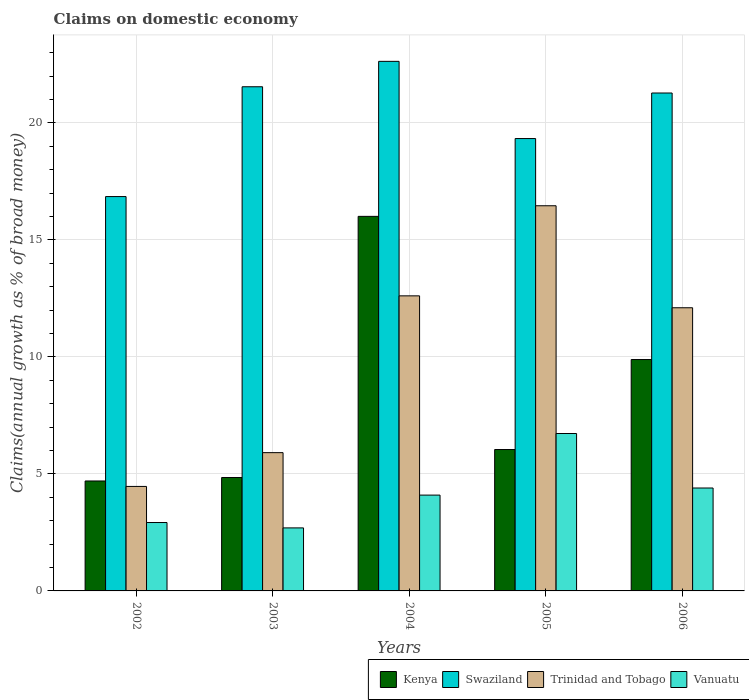How many different coloured bars are there?
Your response must be concise. 4. How many groups of bars are there?
Give a very brief answer. 5. Are the number of bars per tick equal to the number of legend labels?
Offer a terse response. Yes. How many bars are there on the 4th tick from the right?
Provide a short and direct response. 4. In how many cases, is the number of bars for a given year not equal to the number of legend labels?
Provide a succinct answer. 0. What is the percentage of broad money claimed on domestic economy in Kenya in 2004?
Your answer should be very brief. 16. Across all years, what is the maximum percentage of broad money claimed on domestic economy in Kenya?
Ensure brevity in your answer.  16. Across all years, what is the minimum percentage of broad money claimed on domestic economy in Swaziland?
Offer a terse response. 16.85. What is the total percentage of broad money claimed on domestic economy in Kenya in the graph?
Provide a succinct answer. 41.47. What is the difference between the percentage of broad money claimed on domestic economy in Vanuatu in 2004 and that in 2005?
Make the answer very short. -2.63. What is the difference between the percentage of broad money claimed on domestic economy in Swaziland in 2005 and the percentage of broad money claimed on domestic economy in Trinidad and Tobago in 2006?
Provide a short and direct response. 7.23. What is the average percentage of broad money claimed on domestic economy in Swaziland per year?
Your response must be concise. 20.32. In the year 2006, what is the difference between the percentage of broad money claimed on domestic economy in Swaziland and percentage of broad money claimed on domestic economy in Trinidad and Tobago?
Your response must be concise. 9.18. In how many years, is the percentage of broad money claimed on domestic economy in Trinidad and Tobago greater than 1 %?
Your response must be concise. 5. What is the ratio of the percentage of broad money claimed on domestic economy in Vanuatu in 2002 to that in 2004?
Provide a succinct answer. 0.71. What is the difference between the highest and the second highest percentage of broad money claimed on domestic economy in Kenya?
Keep it short and to the point. 6.12. What is the difference between the highest and the lowest percentage of broad money claimed on domestic economy in Kenya?
Your answer should be very brief. 11.31. In how many years, is the percentage of broad money claimed on domestic economy in Trinidad and Tobago greater than the average percentage of broad money claimed on domestic economy in Trinidad and Tobago taken over all years?
Provide a short and direct response. 3. Is the sum of the percentage of broad money claimed on domestic economy in Swaziland in 2003 and 2006 greater than the maximum percentage of broad money claimed on domestic economy in Vanuatu across all years?
Keep it short and to the point. Yes. What does the 4th bar from the left in 2006 represents?
Provide a short and direct response. Vanuatu. What does the 1st bar from the right in 2005 represents?
Make the answer very short. Vanuatu. How many bars are there?
Offer a very short reply. 20. Are all the bars in the graph horizontal?
Your response must be concise. No. How many years are there in the graph?
Your answer should be very brief. 5. Does the graph contain any zero values?
Provide a short and direct response. No. Does the graph contain grids?
Offer a very short reply. Yes. Where does the legend appear in the graph?
Your answer should be compact. Bottom right. How are the legend labels stacked?
Your response must be concise. Horizontal. What is the title of the graph?
Offer a terse response. Claims on domestic economy. What is the label or title of the Y-axis?
Your answer should be very brief. Claims(annual growth as % of broad money). What is the Claims(annual growth as % of broad money) of Kenya in 2002?
Offer a terse response. 4.7. What is the Claims(annual growth as % of broad money) of Swaziland in 2002?
Offer a very short reply. 16.85. What is the Claims(annual growth as % of broad money) in Trinidad and Tobago in 2002?
Offer a very short reply. 4.46. What is the Claims(annual growth as % of broad money) in Vanuatu in 2002?
Make the answer very short. 2.92. What is the Claims(annual growth as % of broad money) of Kenya in 2003?
Ensure brevity in your answer.  4.84. What is the Claims(annual growth as % of broad money) of Swaziland in 2003?
Your response must be concise. 21.54. What is the Claims(annual growth as % of broad money) of Trinidad and Tobago in 2003?
Provide a succinct answer. 5.91. What is the Claims(annual growth as % of broad money) in Vanuatu in 2003?
Keep it short and to the point. 2.69. What is the Claims(annual growth as % of broad money) in Kenya in 2004?
Provide a short and direct response. 16. What is the Claims(annual growth as % of broad money) of Swaziland in 2004?
Your answer should be very brief. 22.63. What is the Claims(annual growth as % of broad money) of Trinidad and Tobago in 2004?
Give a very brief answer. 12.61. What is the Claims(annual growth as % of broad money) of Vanuatu in 2004?
Offer a terse response. 4.09. What is the Claims(annual growth as % of broad money) in Kenya in 2005?
Offer a very short reply. 6.04. What is the Claims(annual growth as % of broad money) of Swaziland in 2005?
Your answer should be very brief. 19.33. What is the Claims(annual growth as % of broad money) in Trinidad and Tobago in 2005?
Provide a succinct answer. 16.46. What is the Claims(annual growth as % of broad money) in Vanuatu in 2005?
Your answer should be very brief. 6.73. What is the Claims(annual growth as % of broad money) of Kenya in 2006?
Give a very brief answer. 9.89. What is the Claims(annual growth as % of broad money) in Swaziland in 2006?
Ensure brevity in your answer.  21.27. What is the Claims(annual growth as % of broad money) in Trinidad and Tobago in 2006?
Your answer should be compact. 12.1. What is the Claims(annual growth as % of broad money) in Vanuatu in 2006?
Offer a terse response. 4.4. Across all years, what is the maximum Claims(annual growth as % of broad money) in Kenya?
Offer a terse response. 16. Across all years, what is the maximum Claims(annual growth as % of broad money) in Swaziland?
Make the answer very short. 22.63. Across all years, what is the maximum Claims(annual growth as % of broad money) in Trinidad and Tobago?
Your answer should be very brief. 16.46. Across all years, what is the maximum Claims(annual growth as % of broad money) in Vanuatu?
Provide a short and direct response. 6.73. Across all years, what is the minimum Claims(annual growth as % of broad money) in Kenya?
Offer a terse response. 4.7. Across all years, what is the minimum Claims(annual growth as % of broad money) in Swaziland?
Offer a very short reply. 16.85. Across all years, what is the minimum Claims(annual growth as % of broad money) in Trinidad and Tobago?
Give a very brief answer. 4.46. Across all years, what is the minimum Claims(annual growth as % of broad money) in Vanuatu?
Offer a terse response. 2.69. What is the total Claims(annual growth as % of broad money) in Kenya in the graph?
Your answer should be compact. 41.47. What is the total Claims(annual growth as % of broad money) of Swaziland in the graph?
Give a very brief answer. 101.62. What is the total Claims(annual growth as % of broad money) of Trinidad and Tobago in the graph?
Offer a very short reply. 51.54. What is the total Claims(annual growth as % of broad money) of Vanuatu in the graph?
Keep it short and to the point. 20.83. What is the difference between the Claims(annual growth as % of broad money) in Kenya in 2002 and that in 2003?
Offer a terse response. -0.15. What is the difference between the Claims(annual growth as % of broad money) of Swaziland in 2002 and that in 2003?
Your answer should be compact. -4.69. What is the difference between the Claims(annual growth as % of broad money) in Trinidad and Tobago in 2002 and that in 2003?
Give a very brief answer. -1.44. What is the difference between the Claims(annual growth as % of broad money) in Vanuatu in 2002 and that in 2003?
Offer a terse response. 0.23. What is the difference between the Claims(annual growth as % of broad money) of Kenya in 2002 and that in 2004?
Offer a terse response. -11.31. What is the difference between the Claims(annual growth as % of broad money) of Swaziland in 2002 and that in 2004?
Give a very brief answer. -5.78. What is the difference between the Claims(annual growth as % of broad money) in Trinidad and Tobago in 2002 and that in 2004?
Offer a very short reply. -8.14. What is the difference between the Claims(annual growth as % of broad money) of Vanuatu in 2002 and that in 2004?
Your answer should be very brief. -1.17. What is the difference between the Claims(annual growth as % of broad money) in Kenya in 2002 and that in 2005?
Provide a succinct answer. -1.34. What is the difference between the Claims(annual growth as % of broad money) in Swaziland in 2002 and that in 2005?
Provide a succinct answer. -2.48. What is the difference between the Claims(annual growth as % of broad money) in Trinidad and Tobago in 2002 and that in 2005?
Offer a very short reply. -11.99. What is the difference between the Claims(annual growth as % of broad money) in Vanuatu in 2002 and that in 2005?
Ensure brevity in your answer.  -3.8. What is the difference between the Claims(annual growth as % of broad money) of Kenya in 2002 and that in 2006?
Ensure brevity in your answer.  -5.19. What is the difference between the Claims(annual growth as % of broad money) of Swaziland in 2002 and that in 2006?
Ensure brevity in your answer.  -4.42. What is the difference between the Claims(annual growth as % of broad money) in Trinidad and Tobago in 2002 and that in 2006?
Your answer should be very brief. -7.63. What is the difference between the Claims(annual growth as % of broad money) in Vanuatu in 2002 and that in 2006?
Ensure brevity in your answer.  -1.48. What is the difference between the Claims(annual growth as % of broad money) in Kenya in 2003 and that in 2004?
Your answer should be compact. -11.16. What is the difference between the Claims(annual growth as % of broad money) of Swaziland in 2003 and that in 2004?
Ensure brevity in your answer.  -1.09. What is the difference between the Claims(annual growth as % of broad money) in Trinidad and Tobago in 2003 and that in 2004?
Provide a succinct answer. -6.7. What is the difference between the Claims(annual growth as % of broad money) of Vanuatu in 2003 and that in 2004?
Your answer should be very brief. -1.4. What is the difference between the Claims(annual growth as % of broad money) of Kenya in 2003 and that in 2005?
Ensure brevity in your answer.  -1.2. What is the difference between the Claims(annual growth as % of broad money) of Swaziland in 2003 and that in 2005?
Your response must be concise. 2.21. What is the difference between the Claims(annual growth as % of broad money) in Trinidad and Tobago in 2003 and that in 2005?
Offer a terse response. -10.55. What is the difference between the Claims(annual growth as % of broad money) of Vanuatu in 2003 and that in 2005?
Keep it short and to the point. -4.03. What is the difference between the Claims(annual growth as % of broad money) of Kenya in 2003 and that in 2006?
Your response must be concise. -5.04. What is the difference between the Claims(annual growth as % of broad money) in Swaziland in 2003 and that in 2006?
Give a very brief answer. 0.27. What is the difference between the Claims(annual growth as % of broad money) of Trinidad and Tobago in 2003 and that in 2006?
Give a very brief answer. -6.19. What is the difference between the Claims(annual growth as % of broad money) in Vanuatu in 2003 and that in 2006?
Give a very brief answer. -1.7. What is the difference between the Claims(annual growth as % of broad money) in Kenya in 2004 and that in 2005?
Offer a very short reply. 9.96. What is the difference between the Claims(annual growth as % of broad money) in Swaziland in 2004 and that in 2005?
Your answer should be very brief. 3.3. What is the difference between the Claims(annual growth as % of broad money) of Trinidad and Tobago in 2004 and that in 2005?
Make the answer very short. -3.85. What is the difference between the Claims(annual growth as % of broad money) of Vanuatu in 2004 and that in 2005?
Offer a very short reply. -2.63. What is the difference between the Claims(annual growth as % of broad money) in Kenya in 2004 and that in 2006?
Offer a terse response. 6.12. What is the difference between the Claims(annual growth as % of broad money) of Swaziland in 2004 and that in 2006?
Provide a short and direct response. 1.35. What is the difference between the Claims(annual growth as % of broad money) of Trinidad and Tobago in 2004 and that in 2006?
Make the answer very short. 0.51. What is the difference between the Claims(annual growth as % of broad money) in Vanuatu in 2004 and that in 2006?
Offer a terse response. -0.3. What is the difference between the Claims(annual growth as % of broad money) in Kenya in 2005 and that in 2006?
Offer a very short reply. -3.84. What is the difference between the Claims(annual growth as % of broad money) of Swaziland in 2005 and that in 2006?
Give a very brief answer. -1.95. What is the difference between the Claims(annual growth as % of broad money) in Trinidad and Tobago in 2005 and that in 2006?
Ensure brevity in your answer.  4.36. What is the difference between the Claims(annual growth as % of broad money) in Vanuatu in 2005 and that in 2006?
Provide a succinct answer. 2.33. What is the difference between the Claims(annual growth as % of broad money) of Kenya in 2002 and the Claims(annual growth as % of broad money) of Swaziland in 2003?
Your answer should be very brief. -16.84. What is the difference between the Claims(annual growth as % of broad money) in Kenya in 2002 and the Claims(annual growth as % of broad money) in Trinidad and Tobago in 2003?
Offer a terse response. -1.21. What is the difference between the Claims(annual growth as % of broad money) in Kenya in 2002 and the Claims(annual growth as % of broad money) in Vanuatu in 2003?
Make the answer very short. 2. What is the difference between the Claims(annual growth as % of broad money) of Swaziland in 2002 and the Claims(annual growth as % of broad money) of Trinidad and Tobago in 2003?
Offer a terse response. 10.94. What is the difference between the Claims(annual growth as % of broad money) of Swaziland in 2002 and the Claims(annual growth as % of broad money) of Vanuatu in 2003?
Make the answer very short. 14.16. What is the difference between the Claims(annual growth as % of broad money) of Trinidad and Tobago in 2002 and the Claims(annual growth as % of broad money) of Vanuatu in 2003?
Your response must be concise. 1.77. What is the difference between the Claims(annual growth as % of broad money) of Kenya in 2002 and the Claims(annual growth as % of broad money) of Swaziland in 2004?
Offer a terse response. -17.93. What is the difference between the Claims(annual growth as % of broad money) of Kenya in 2002 and the Claims(annual growth as % of broad money) of Trinidad and Tobago in 2004?
Your response must be concise. -7.91. What is the difference between the Claims(annual growth as % of broad money) in Kenya in 2002 and the Claims(annual growth as % of broad money) in Vanuatu in 2004?
Your answer should be very brief. 0.6. What is the difference between the Claims(annual growth as % of broad money) in Swaziland in 2002 and the Claims(annual growth as % of broad money) in Trinidad and Tobago in 2004?
Provide a succinct answer. 4.24. What is the difference between the Claims(annual growth as % of broad money) in Swaziland in 2002 and the Claims(annual growth as % of broad money) in Vanuatu in 2004?
Offer a terse response. 12.76. What is the difference between the Claims(annual growth as % of broad money) in Trinidad and Tobago in 2002 and the Claims(annual growth as % of broad money) in Vanuatu in 2004?
Provide a short and direct response. 0.37. What is the difference between the Claims(annual growth as % of broad money) in Kenya in 2002 and the Claims(annual growth as % of broad money) in Swaziland in 2005?
Your answer should be compact. -14.63. What is the difference between the Claims(annual growth as % of broad money) in Kenya in 2002 and the Claims(annual growth as % of broad money) in Trinidad and Tobago in 2005?
Ensure brevity in your answer.  -11.76. What is the difference between the Claims(annual growth as % of broad money) in Kenya in 2002 and the Claims(annual growth as % of broad money) in Vanuatu in 2005?
Provide a short and direct response. -2.03. What is the difference between the Claims(annual growth as % of broad money) in Swaziland in 2002 and the Claims(annual growth as % of broad money) in Trinidad and Tobago in 2005?
Keep it short and to the point. 0.39. What is the difference between the Claims(annual growth as % of broad money) in Swaziland in 2002 and the Claims(annual growth as % of broad money) in Vanuatu in 2005?
Keep it short and to the point. 10.12. What is the difference between the Claims(annual growth as % of broad money) of Trinidad and Tobago in 2002 and the Claims(annual growth as % of broad money) of Vanuatu in 2005?
Offer a terse response. -2.26. What is the difference between the Claims(annual growth as % of broad money) of Kenya in 2002 and the Claims(annual growth as % of broad money) of Swaziland in 2006?
Your response must be concise. -16.58. What is the difference between the Claims(annual growth as % of broad money) in Kenya in 2002 and the Claims(annual growth as % of broad money) in Trinidad and Tobago in 2006?
Your answer should be very brief. -7.4. What is the difference between the Claims(annual growth as % of broad money) of Kenya in 2002 and the Claims(annual growth as % of broad money) of Vanuatu in 2006?
Your answer should be very brief. 0.3. What is the difference between the Claims(annual growth as % of broad money) of Swaziland in 2002 and the Claims(annual growth as % of broad money) of Trinidad and Tobago in 2006?
Offer a very short reply. 4.75. What is the difference between the Claims(annual growth as % of broad money) of Swaziland in 2002 and the Claims(annual growth as % of broad money) of Vanuatu in 2006?
Keep it short and to the point. 12.45. What is the difference between the Claims(annual growth as % of broad money) in Trinidad and Tobago in 2002 and the Claims(annual growth as % of broad money) in Vanuatu in 2006?
Your response must be concise. 0.07. What is the difference between the Claims(annual growth as % of broad money) of Kenya in 2003 and the Claims(annual growth as % of broad money) of Swaziland in 2004?
Ensure brevity in your answer.  -17.78. What is the difference between the Claims(annual growth as % of broad money) in Kenya in 2003 and the Claims(annual growth as % of broad money) in Trinidad and Tobago in 2004?
Your answer should be compact. -7.76. What is the difference between the Claims(annual growth as % of broad money) in Kenya in 2003 and the Claims(annual growth as % of broad money) in Vanuatu in 2004?
Keep it short and to the point. 0.75. What is the difference between the Claims(annual growth as % of broad money) of Swaziland in 2003 and the Claims(annual growth as % of broad money) of Trinidad and Tobago in 2004?
Ensure brevity in your answer.  8.93. What is the difference between the Claims(annual growth as % of broad money) of Swaziland in 2003 and the Claims(annual growth as % of broad money) of Vanuatu in 2004?
Your answer should be very brief. 17.45. What is the difference between the Claims(annual growth as % of broad money) in Trinidad and Tobago in 2003 and the Claims(annual growth as % of broad money) in Vanuatu in 2004?
Give a very brief answer. 1.81. What is the difference between the Claims(annual growth as % of broad money) of Kenya in 2003 and the Claims(annual growth as % of broad money) of Swaziland in 2005?
Your answer should be compact. -14.48. What is the difference between the Claims(annual growth as % of broad money) of Kenya in 2003 and the Claims(annual growth as % of broad money) of Trinidad and Tobago in 2005?
Make the answer very short. -11.61. What is the difference between the Claims(annual growth as % of broad money) of Kenya in 2003 and the Claims(annual growth as % of broad money) of Vanuatu in 2005?
Keep it short and to the point. -1.88. What is the difference between the Claims(annual growth as % of broad money) in Swaziland in 2003 and the Claims(annual growth as % of broad money) in Trinidad and Tobago in 2005?
Provide a short and direct response. 5.08. What is the difference between the Claims(annual growth as % of broad money) of Swaziland in 2003 and the Claims(annual growth as % of broad money) of Vanuatu in 2005?
Give a very brief answer. 14.82. What is the difference between the Claims(annual growth as % of broad money) of Trinidad and Tobago in 2003 and the Claims(annual growth as % of broad money) of Vanuatu in 2005?
Ensure brevity in your answer.  -0.82. What is the difference between the Claims(annual growth as % of broad money) in Kenya in 2003 and the Claims(annual growth as % of broad money) in Swaziland in 2006?
Offer a terse response. -16.43. What is the difference between the Claims(annual growth as % of broad money) in Kenya in 2003 and the Claims(annual growth as % of broad money) in Trinidad and Tobago in 2006?
Your response must be concise. -7.25. What is the difference between the Claims(annual growth as % of broad money) in Kenya in 2003 and the Claims(annual growth as % of broad money) in Vanuatu in 2006?
Provide a short and direct response. 0.45. What is the difference between the Claims(annual growth as % of broad money) in Swaziland in 2003 and the Claims(annual growth as % of broad money) in Trinidad and Tobago in 2006?
Offer a very short reply. 9.44. What is the difference between the Claims(annual growth as % of broad money) in Swaziland in 2003 and the Claims(annual growth as % of broad money) in Vanuatu in 2006?
Give a very brief answer. 17.14. What is the difference between the Claims(annual growth as % of broad money) of Trinidad and Tobago in 2003 and the Claims(annual growth as % of broad money) of Vanuatu in 2006?
Give a very brief answer. 1.51. What is the difference between the Claims(annual growth as % of broad money) in Kenya in 2004 and the Claims(annual growth as % of broad money) in Swaziland in 2005?
Offer a very short reply. -3.32. What is the difference between the Claims(annual growth as % of broad money) of Kenya in 2004 and the Claims(annual growth as % of broad money) of Trinidad and Tobago in 2005?
Provide a succinct answer. -0.45. What is the difference between the Claims(annual growth as % of broad money) in Kenya in 2004 and the Claims(annual growth as % of broad money) in Vanuatu in 2005?
Your answer should be very brief. 9.28. What is the difference between the Claims(annual growth as % of broad money) in Swaziland in 2004 and the Claims(annual growth as % of broad money) in Trinidad and Tobago in 2005?
Keep it short and to the point. 6.17. What is the difference between the Claims(annual growth as % of broad money) in Swaziland in 2004 and the Claims(annual growth as % of broad money) in Vanuatu in 2005?
Give a very brief answer. 15.9. What is the difference between the Claims(annual growth as % of broad money) in Trinidad and Tobago in 2004 and the Claims(annual growth as % of broad money) in Vanuatu in 2005?
Ensure brevity in your answer.  5.88. What is the difference between the Claims(annual growth as % of broad money) of Kenya in 2004 and the Claims(annual growth as % of broad money) of Swaziland in 2006?
Give a very brief answer. -5.27. What is the difference between the Claims(annual growth as % of broad money) of Kenya in 2004 and the Claims(annual growth as % of broad money) of Trinidad and Tobago in 2006?
Make the answer very short. 3.91. What is the difference between the Claims(annual growth as % of broad money) in Kenya in 2004 and the Claims(annual growth as % of broad money) in Vanuatu in 2006?
Keep it short and to the point. 11.61. What is the difference between the Claims(annual growth as % of broad money) of Swaziland in 2004 and the Claims(annual growth as % of broad money) of Trinidad and Tobago in 2006?
Your response must be concise. 10.53. What is the difference between the Claims(annual growth as % of broad money) of Swaziland in 2004 and the Claims(annual growth as % of broad money) of Vanuatu in 2006?
Provide a short and direct response. 18.23. What is the difference between the Claims(annual growth as % of broad money) of Trinidad and Tobago in 2004 and the Claims(annual growth as % of broad money) of Vanuatu in 2006?
Offer a very short reply. 8.21. What is the difference between the Claims(annual growth as % of broad money) in Kenya in 2005 and the Claims(annual growth as % of broad money) in Swaziland in 2006?
Offer a terse response. -15.23. What is the difference between the Claims(annual growth as % of broad money) in Kenya in 2005 and the Claims(annual growth as % of broad money) in Trinidad and Tobago in 2006?
Your answer should be compact. -6.06. What is the difference between the Claims(annual growth as % of broad money) of Kenya in 2005 and the Claims(annual growth as % of broad money) of Vanuatu in 2006?
Give a very brief answer. 1.64. What is the difference between the Claims(annual growth as % of broad money) in Swaziland in 2005 and the Claims(annual growth as % of broad money) in Trinidad and Tobago in 2006?
Keep it short and to the point. 7.23. What is the difference between the Claims(annual growth as % of broad money) in Swaziland in 2005 and the Claims(annual growth as % of broad money) in Vanuatu in 2006?
Make the answer very short. 14.93. What is the difference between the Claims(annual growth as % of broad money) of Trinidad and Tobago in 2005 and the Claims(annual growth as % of broad money) of Vanuatu in 2006?
Your response must be concise. 12.06. What is the average Claims(annual growth as % of broad money) in Kenya per year?
Your response must be concise. 8.29. What is the average Claims(annual growth as % of broad money) of Swaziland per year?
Your response must be concise. 20.32. What is the average Claims(annual growth as % of broad money) of Trinidad and Tobago per year?
Your answer should be very brief. 10.31. What is the average Claims(annual growth as % of broad money) in Vanuatu per year?
Give a very brief answer. 4.17. In the year 2002, what is the difference between the Claims(annual growth as % of broad money) of Kenya and Claims(annual growth as % of broad money) of Swaziland?
Provide a succinct answer. -12.15. In the year 2002, what is the difference between the Claims(annual growth as % of broad money) in Kenya and Claims(annual growth as % of broad money) in Trinidad and Tobago?
Offer a terse response. 0.23. In the year 2002, what is the difference between the Claims(annual growth as % of broad money) of Kenya and Claims(annual growth as % of broad money) of Vanuatu?
Ensure brevity in your answer.  1.78. In the year 2002, what is the difference between the Claims(annual growth as % of broad money) of Swaziland and Claims(annual growth as % of broad money) of Trinidad and Tobago?
Provide a short and direct response. 12.39. In the year 2002, what is the difference between the Claims(annual growth as % of broad money) in Swaziland and Claims(annual growth as % of broad money) in Vanuatu?
Offer a terse response. 13.93. In the year 2002, what is the difference between the Claims(annual growth as % of broad money) in Trinidad and Tobago and Claims(annual growth as % of broad money) in Vanuatu?
Offer a terse response. 1.54. In the year 2003, what is the difference between the Claims(annual growth as % of broad money) in Kenya and Claims(annual growth as % of broad money) in Swaziland?
Make the answer very short. -16.7. In the year 2003, what is the difference between the Claims(annual growth as % of broad money) of Kenya and Claims(annual growth as % of broad money) of Trinidad and Tobago?
Provide a succinct answer. -1.06. In the year 2003, what is the difference between the Claims(annual growth as % of broad money) of Kenya and Claims(annual growth as % of broad money) of Vanuatu?
Your answer should be very brief. 2.15. In the year 2003, what is the difference between the Claims(annual growth as % of broad money) in Swaziland and Claims(annual growth as % of broad money) in Trinidad and Tobago?
Give a very brief answer. 15.63. In the year 2003, what is the difference between the Claims(annual growth as % of broad money) of Swaziland and Claims(annual growth as % of broad money) of Vanuatu?
Keep it short and to the point. 18.85. In the year 2003, what is the difference between the Claims(annual growth as % of broad money) of Trinidad and Tobago and Claims(annual growth as % of broad money) of Vanuatu?
Your answer should be very brief. 3.22. In the year 2004, what is the difference between the Claims(annual growth as % of broad money) of Kenya and Claims(annual growth as % of broad money) of Swaziland?
Ensure brevity in your answer.  -6.62. In the year 2004, what is the difference between the Claims(annual growth as % of broad money) of Kenya and Claims(annual growth as % of broad money) of Trinidad and Tobago?
Keep it short and to the point. 3.4. In the year 2004, what is the difference between the Claims(annual growth as % of broad money) in Kenya and Claims(annual growth as % of broad money) in Vanuatu?
Offer a very short reply. 11.91. In the year 2004, what is the difference between the Claims(annual growth as % of broad money) of Swaziland and Claims(annual growth as % of broad money) of Trinidad and Tobago?
Make the answer very short. 10.02. In the year 2004, what is the difference between the Claims(annual growth as % of broad money) of Swaziland and Claims(annual growth as % of broad money) of Vanuatu?
Offer a terse response. 18.53. In the year 2004, what is the difference between the Claims(annual growth as % of broad money) of Trinidad and Tobago and Claims(annual growth as % of broad money) of Vanuatu?
Keep it short and to the point. 8.51. In the year 2005, what is the difference between the Claims(annual growth as % of broad money) in Kenya and Claims(annual growth as % of broad money) in Swaziland?
Your response must be concise. -13.29. In the year 2005, what is the difference between the Claims(annual growth as % of broad money) of Kenya and Claims(annual growth as % of broad money) of Trinidad and Tobago?
Ensure brevity in your answer.  -10.42. In the year 2005, what is the difference between the Claims(annual growth as % of broad money) of Kenya and Claims(annual growth as % of broad money) of Vanuatu?
Make the answer very short. -0.68. In the year 2005, what is the difference between the Claims(annual growth as % of broad money) of Swaziland and Claims(annual growth as % of broad money) of Trinidad and Tobago?
Provide a succinct answer. 2.87. In the year 2005, what is the difference between the Claims(annual growth as % of broad money) of Swaziland and Claims(annual growth as % of broad money) of Vanuatu?
Your answer should be very brief. 12.6. In the year 2005, what is the difference between the Claims(annual growth as % of broad money) in Trinidad and Tobago and Claims(annual growth as % of broad money) in Vanuatu?
Ensure brevity in your answer.  9.73. In the year 2006, what is the difference between the Claims(annual growth as % of broad money) of Kenya and Claims(annual growth as % of broad money) of Swaziland?
Offer a very short reply. -11.39. In the year 2006, what is the difference between the Claims(annual growth as % of broad money) in Kenya and Claims(annual growth as % of broad money) in Trinidad and Tobago?
Keep it short and to the point. -2.21. In the year 2006, what is the difference between the Claims(annual growth as % of broad money) in Kenya and Claims(annual growth as % of broad money) in Vanuatu?
Provide a short and direct response. 5.49. In the year 2006, what is the difference between the Claims(annual growth as % of broad money) of Swaziland and Claims(annual growth as % of broad money) of Trinidad and Tobago?
Ensure brevity in your answer.  9.18. In the year 2006, what is the difference between the Claims(annual growth as % of broad money) of Swaziland and Claims(annual growth as % of broad money) of Vanuatu?
Provide a short and direct response. 16.88. In the year 2006, what is the difference between the Claims(annual growth as % of broad money) in Trinidad and Tobago and Claims(annual growth as % of broad money) in Vanuatu?
Your response must be concise. 7.7. What is the ratio of the Claims(annual growth as % of broad money) of Kenya in 2002 to that in 2003?
Give a very brief answer. 0.97. What is the ratio of the Claims(annual growth as % of broad money) of Swaziland in 2002 to that in 2003?
Ensure brevity in your answer.  0.78. What is the ratio of the Claims(annual growth as % of broad money) of Trinidad and Tobago in 2002 to that in 2003?
Provide a short and direct response. 0.76. What is the ratio of the Claims(annual growth as % of broad money) in Vanuatu in 2002 to that in 2003?
Your answer should be very brief. 1.09. What is the ratio of the Claims(annual growth as % of broad money) in Kenya in 2002 to that in 2004?
Make the answer very short. 0.29. What is the ratio of the Claims(annual growth as % of broad money) of Swaziland in 2002 to that in 2004?
Your response must be concise. 0.74. What is the ratio of the Claims(annual growth as % of broad money) of Trinidad and Tobago in 2002 to that in 2004?
Provide a succinct answer. 0.35. What is the ratio of the Claims(annual growth as % of broad money) of Vanuatu in 2002 to that in 2004?
Provide a succinct answer. 0.71. What is the ratio of the Claims(annual growth as % of broad money) in Kenya in 2002 to that in 2005?
Offer a very short reply. 0.78. What is the ratio of the Claims(annual growth as % of broad money) of Swaziland in 2002 to that in 2005?
Give a very brief answer. 0.87. What is the ratio of the Claims(annual growth as % of broad money) of Trinidad and Tobago in 2002 to that in 2005?
Provide a short and direct response. 0.27. What is the ratio of the Claims(annual growth as % of broad money) of Vanuatu in 2002 to that in 2005?
Give a very brief answer. 0.43. What is the ratio of the Claims(annual growth as % of broad money) in Kenya in 2002 to that in 2006?
Keep it short and to the point. 0.48. What is the ratio of the Claims(annual growth as % of broad money) of Swaziland in 2002 to that in 2006?
Make the answer very short. 0.79. What is the ratio of the Claims(annual growth as % of broad money) of Trinidad and Tobago in 2002 to that in 2006?
Keep it short and to the point. 0.37. What is the ratio of the Claims(annual growth as % of broad money) of Vanuatu in 2002 to that in 2006?
Provide a succinct answer. 0.66. What is the ratio of the Claims(annual growth as % of broad money) of Kenya in 2003 to that in 2004?
Keep it short and to the point. 0.3. What is the ratio of the Claims(annual growth as % of broad money) in Trinidad and Tobago in 2003 to that in 2004?
Make the answer very short. 0.47. What is the ratio of the Claims(annual growth as % of broad money) in Vanuatu in 2003 to that in 2004?
Your response must be concise. 0.66. What is the ratio of the Claims(annual growth as % of broad money) of Kenya in 2003 to that in 2005?
Make the answer very short. 0.8. What is the ratio of the Claims(annual growth as % of broad money) in Swaziland in 2003 to that in 2005?
Ensure brevity in your answer.  1.11. What is the ratio of the Claims(annual growth as % of broad money) of Trinidad and Tobago in 2003 to that in 2005?
Your answer should be very brief. 0.36. What is the ratio of the Claims(annual growth as % of broad money) in Vanuatu in 2003 to that in 2005?
Ensure brevity in your answer.  0.4. What is the ratio of the Claims(annual growth as % of broad money) in Kenya in 2003 to that in 2006?
Ensure brevity in your answer.  0.49. What is the ratio of the Claims(annual growth as % of broad money) of Swaziland in 2003 to that in 2006?
Your response must be concise. 1.01. What is the ratio of the Claims(annual growth as % of broad money) of Trinidad and Tobago in 2003 to that in 2006?
Provide a short and direct response. 0.49. What is the ratio of the Claims(annual growth as % of broad money) of Vanuatu in 2003 to that in 2006?
Your response must be concise. 0.61. What is the ratio of the Claims(annual growth as % of broad money) in Kenya in 2004 to that in 2005?
Make the answer very short. 2.65. What is the ratio of the Claims(annual growth as % of broad money) of Swaziland in 2004 to that in 2005?
Keep it short and to the point. 1.17. What is the ratio of the Claims(annual growth as % of broad money) in Trinidad and Tobago in 2004 to that in 2005?
Offer a terse response. 0.77. What is the ratio of the Claims(annual growth as % of broad money) of Vanuatu in 2004 to that in 2005?
Provide a short and direct response. 0.61. What is the ratio of the Claims(annual growth as % of broad money) in Kenya in 2004 to that in 2006?
Your response must be concise. 1.62. What is the ratio of the Claims(annual growth as % of broad money) in Swaziland in 2004 to that in 2006?
Offer a very short reply. 1.06. What is the ratio of the Claims(annual growth as % of broad money) in Trinidad and Tobago in 2004 to that in 2006?
Ensure brevity in your answer.  1.04. What is the ratio of the Claims(annual growth as % of broad money) of Vanuatu in 2004 to that in 2006?
Keep it short and to the point. 0.93. What is the ratio of the Claims(annual growth as % of broad money) of Kenya in 2005 to that in 2006?
Offer a very short reply. 0.61. What is the ratio of the Claims(annual growth as % of broad money) of Swaziland in 2005 to that in 2006?
Your response must be concise. 0.91. What is the ratio of the Claims(annual growth as % of broad money) in Trinidad and Tobago in 2005 to that in 2006?
Provide a succinct answer. 1.36. What is the ratio of the Claims(annual growth as % of broad money) in Vanuatu in 2005 to that in 2006?
Make the answer very short. 1.53. What is the difference between the highest and the second highest Claims(annual growth as % of broad money) in Kenya?
Provide a short and direct response. 6.12. What is the difference between the highest and the second highest Claims(annual growth as % of broad money) of Swaziland?
Offer a very short reply. 1.09. What is the difference between the highest and the second highest Claims(annual growth as % of broad money) in Trinidad and Tobago?
Your answer should be compact. 3.85. What is the difference between the highest and the second highest Claims(annual growth as % of broad money) of Vanuatu?
Ensure brevity in your answer.  2.33. What is the difference between the highest and the lowest Claims(annual growth as % of broad money) of Kenya?
Give a very brief answer. 11.31. What is the difference between the highest and the lowest Claims(annual growth as % of broad money) in Swaziland?
Provide a short and direct response. 5.78. What is the difference between the highest and the lowest Claims(annual growth as % of broad money) in Trinidad and Tobago?
Provide a succinct answer. 11.99. What is the difference between the highest and the lowest Claims(annual growth as % of broad money) in Vanuatu?
Provide a succinct answer. 4.03. 